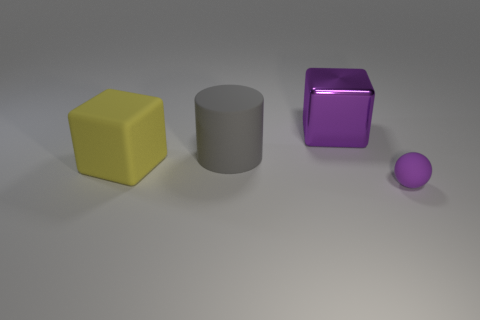There is a large object that is the same color as the tiny rubber thing; what shape is it?
Your response must be concise. Cube. Do the rubber cylinder and the yellow object have the same size?
Offer a very short reply. Yes. How many objects are either things that are in front of the large metallic block or objects that are on the left side of the small purple matte thing?
Make the answer very short. 4. How many large metal things are to the left of the purple object that is behind the rubber thing in front of the big yellow cube?
Give a very brief answer. 0. There is a matte thing that is in front of the yellow rubber cube; how big is it?
Ensure brevity in your answer.  Small. What number of matte spheres have the same size as the gray thing?
Your answer should be very brief. 0. There is a matte cylinder; does it have the same size as the purple object that is left of the rubber sphere?
Provide a succinct answer. Yes. What number of objects are big rubber cylinders or large matte things?
Offer a terse response. 2. How many matte spheres have the same color as the large metal block?
Your answer should be very brief. 1. What is the shape of the yellow object that is the same size as the purple metallic block?
Provide a succinct answer. Cube. 